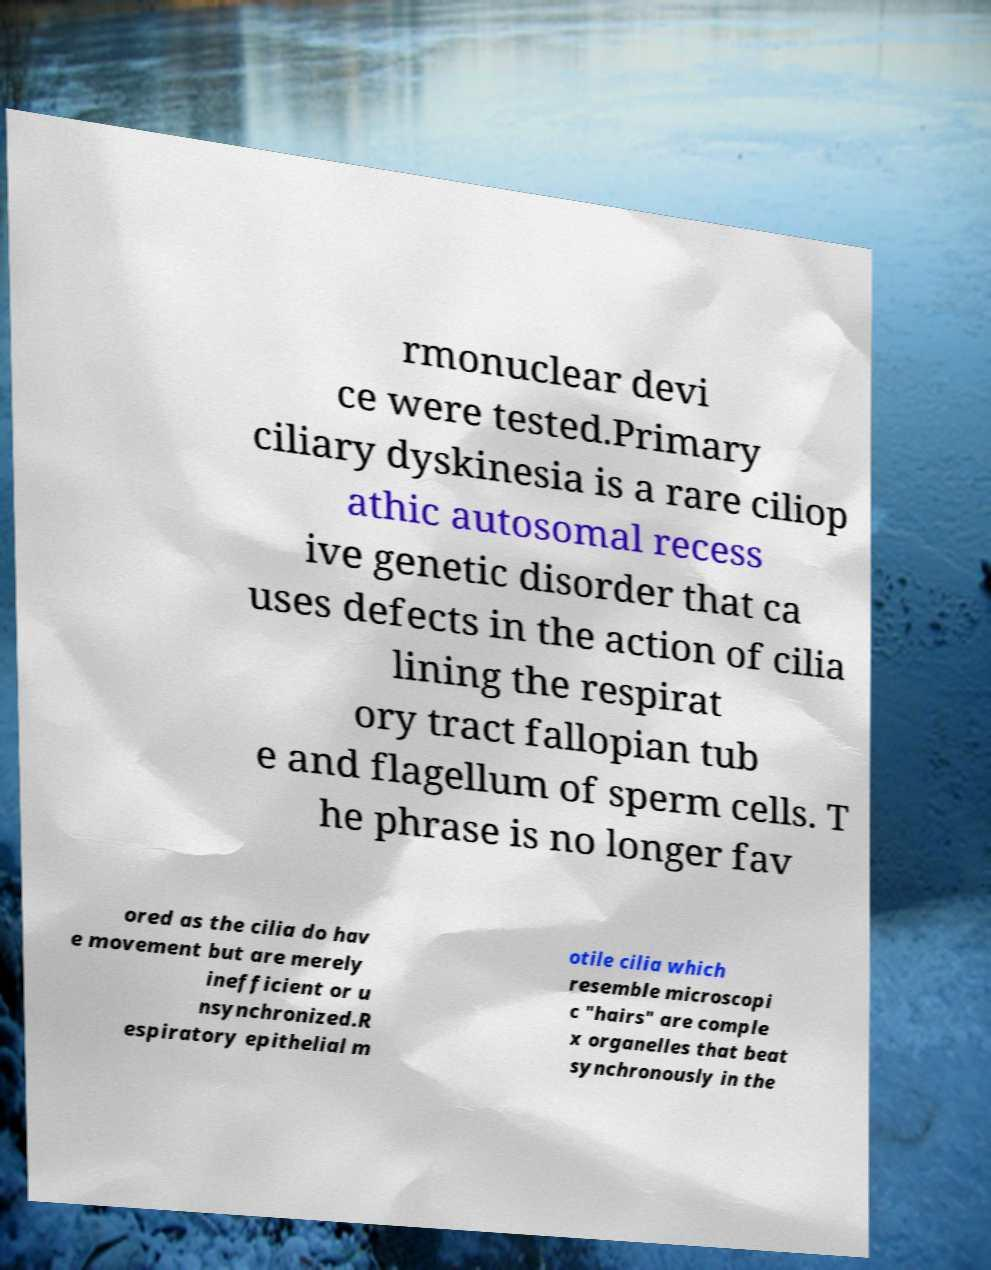Can you read and provide the text displayed in the image?This photo seems to have some interesting text. Can you extract and type it out for me? rmonuclear devi ce were tested.Primary ciliary dyskinesia is a rare ciliop athic autosomal recess ive genetic disorder that ca uses defects in the action of cilia lining the respirat ory tract fallopian tub e and flagellum of sperm cells. T he phrase is no longer fav ored as the cilia do hav e movement but are merely inefficient or u nsynchronized.R espiratory epithelial m otile cilia which resemble microscopi c "hairs" are comple x organelles that beat synchronously in the 